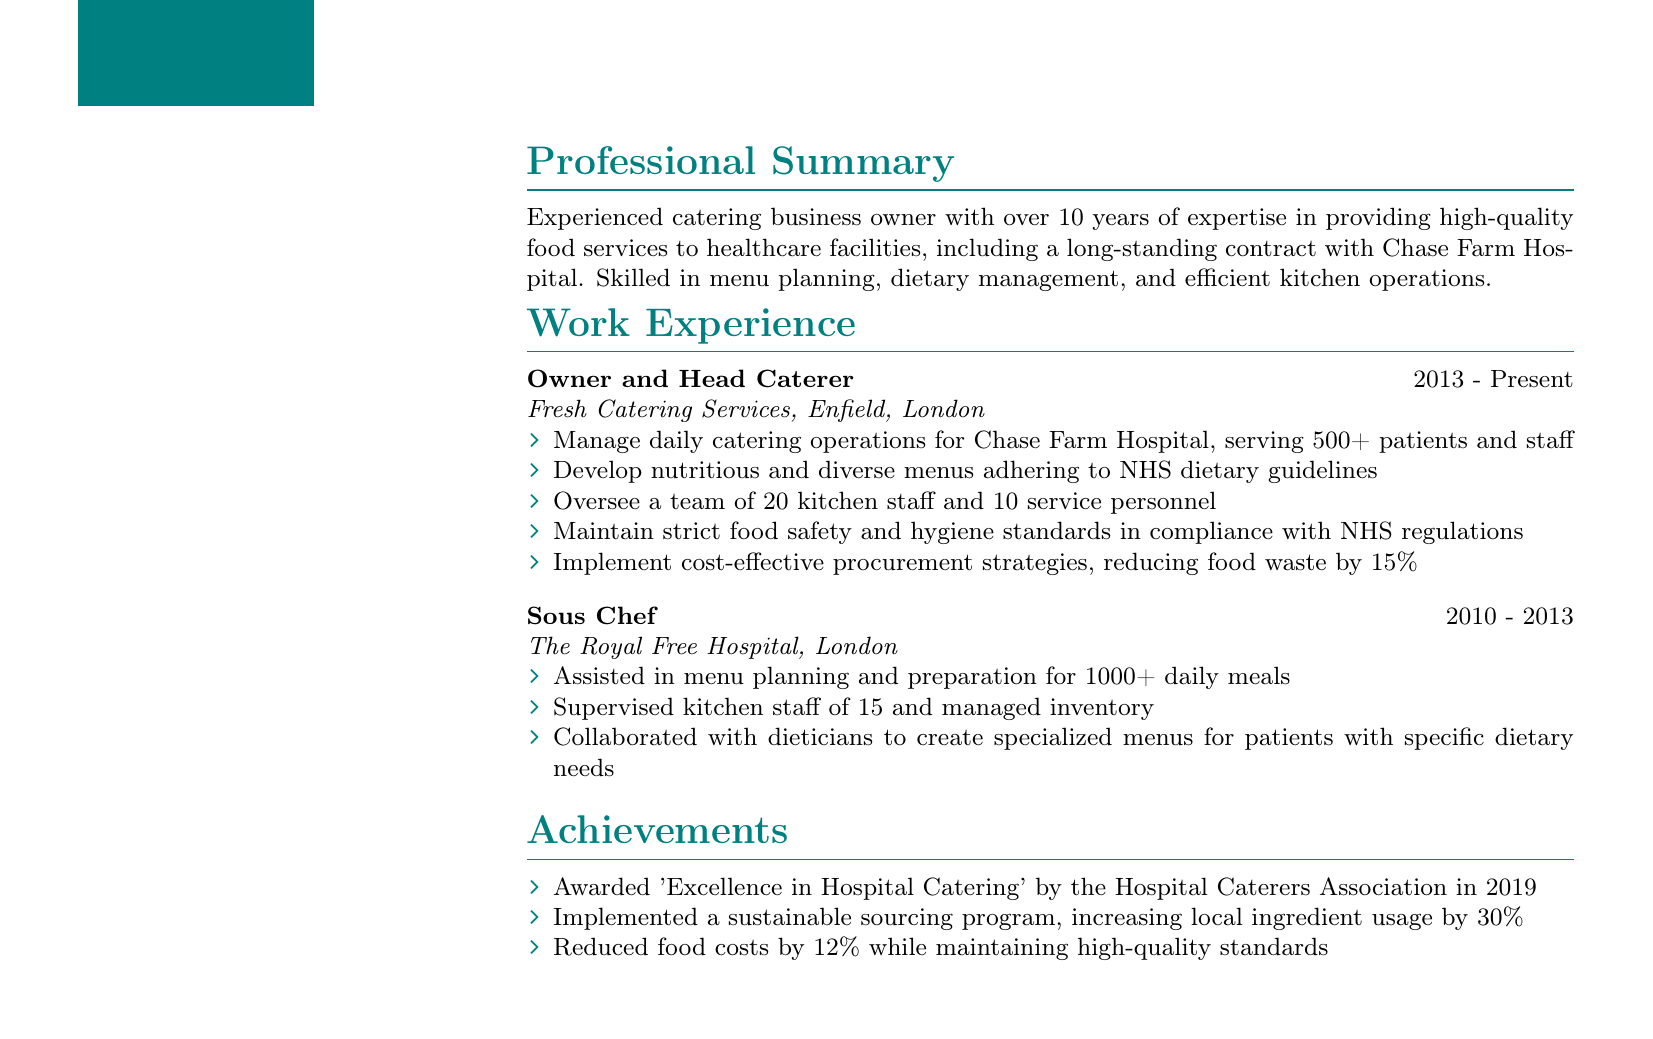What is the name of the business owner? The name is provided in the personal information section of the document.
Answer: Sarah Thompson What is the duration of Sarah's current role? The duration is located in the work experience section under her current job title.
Answer: 2013 - Present How many patients and staff does Sarah's catering service serve daily? This information is found in her list of responsibilities under the current role.
Answer: 500+ What award did Sarah receive in 2019? The award name is listed in the achievements section of the document.
Answer: Excellence in Hospital Catering What degree does Sarah hold? The degree information can be found in the education section of the document.
Answer: BSc in Hospitality Management What is the location of Sarah's business? The location is mentioned in the work experience section under her business name.
Answer: Enfield, London How many kitchen staff does she oversee? This detail is mentioned in the responsibilities of her current role.
Answer: 20 What is one of Sarah's skills related to dietary requirements? Skills related to dietary requirements are listed in the skills section of the document.
Answer: Dietary requirement expertise (e.g., gluten-free, diabetic, kosher) What percentage of food waste was reduced through procurement strategies? This percentage is specified in the responsibilities of her current role.
Answer: 15% 